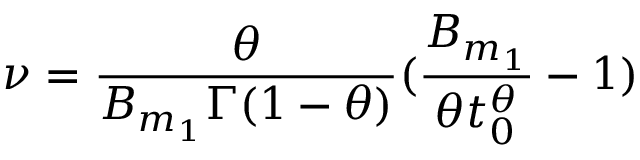<formula> <loc_0><loc_0><loc_500><loc_500>\nu = \frac { \theta } { B _ { m _ { 1 } } \Gamma ( 1 - \theta ) } ( \frac { B _ { m _ { 1 } } } { \theta t _ { 0 } ^ { \theta } } - 1 )</formula> 